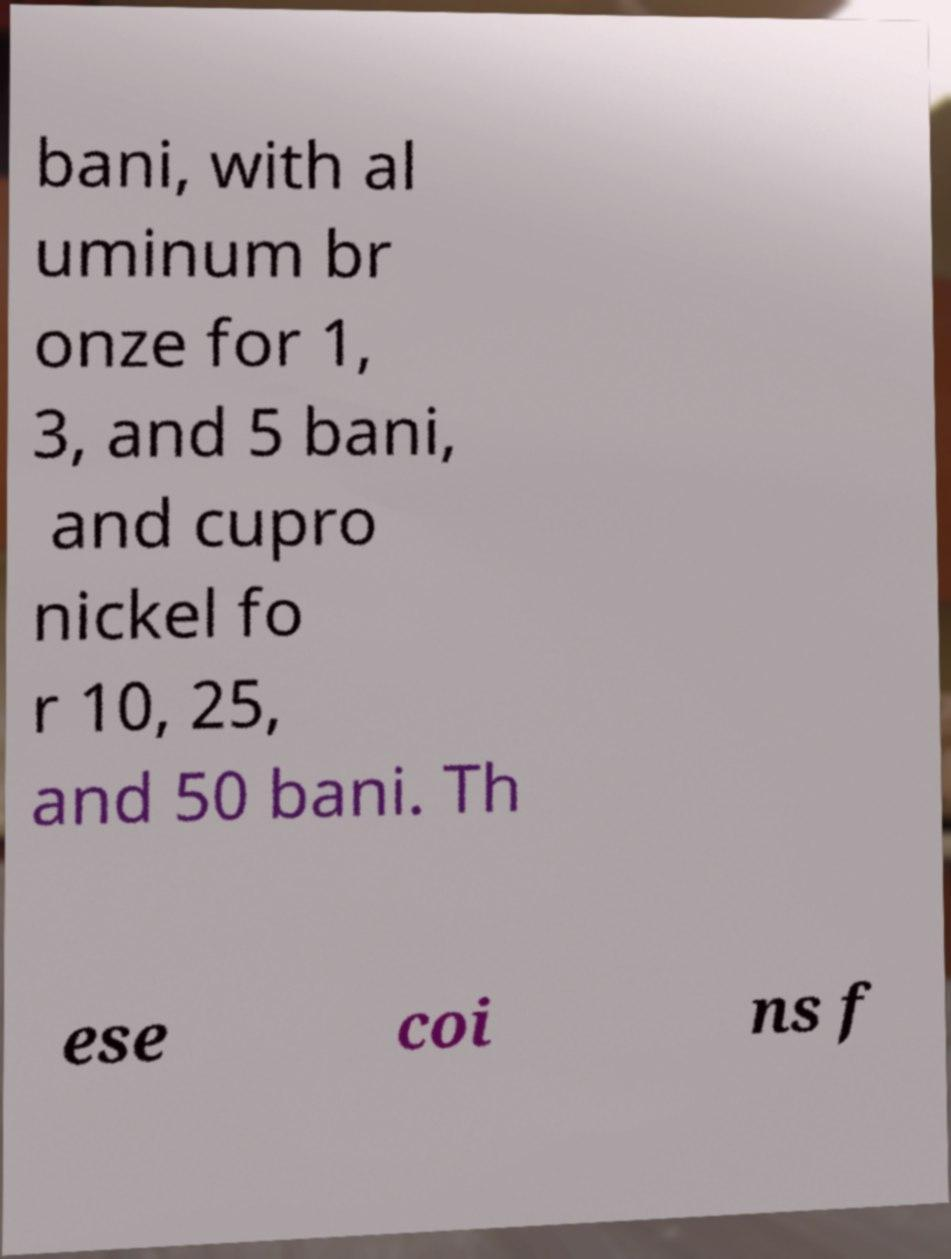There's text embedded in this image that I need extracted. Can you transcribe it verbatim? bani, with al uminum br onze for 1, 3, and 5 bani, and cupro nickel fo r 10, 25, and 50 bani. Th ese coi ns f 